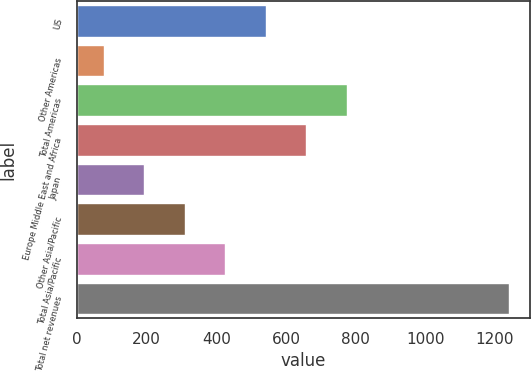Convert chart. <chart><loc_0><loc_0><loc_500><loc_500><bar_chart><fcel>US<fcel>Other Americas<fcel>Total Americas<fcel>Europe Middle East and Africa<fcel>Japan<fcel>Other Asia/Pacific<fcel>Total Asia/Pacific<fcel>Total net revenues<nl><fcel>541.4<fcel>76.4<fcel>773.9<fcel>657.65<fcel>192.65<fcel>308.9<fcel>425.15<fcel>1238.9<nl></chart> 